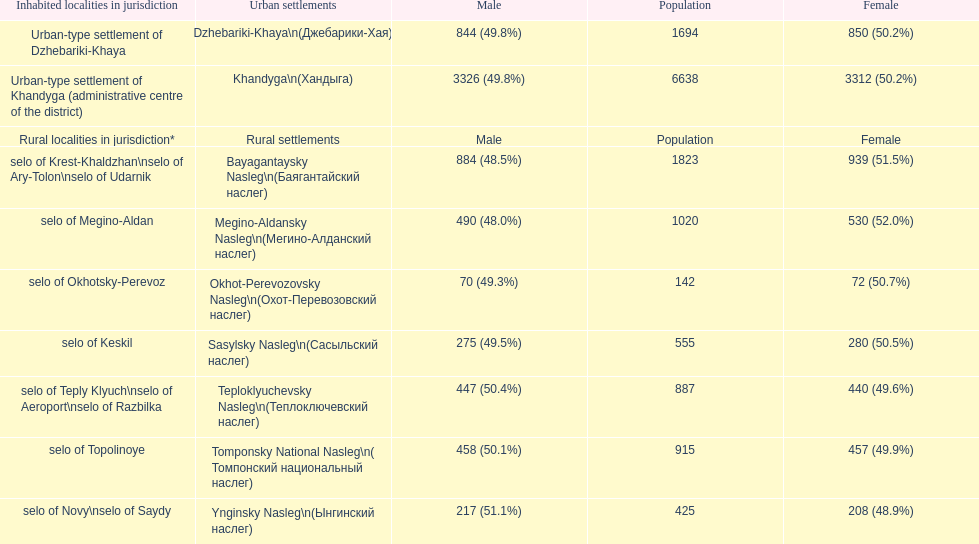Which rural settlement has the most males in their population? Bayagantaysky Nasleg (Áàÿãàíòàéñêèé íàñëåã). 